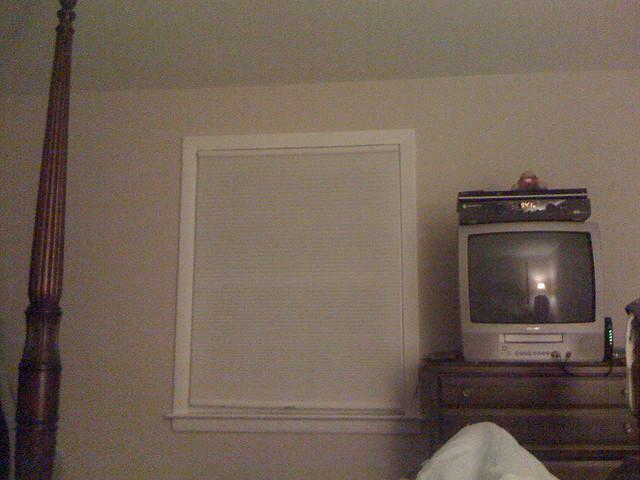How many windows are there?
Give a very brief answer. 1. 